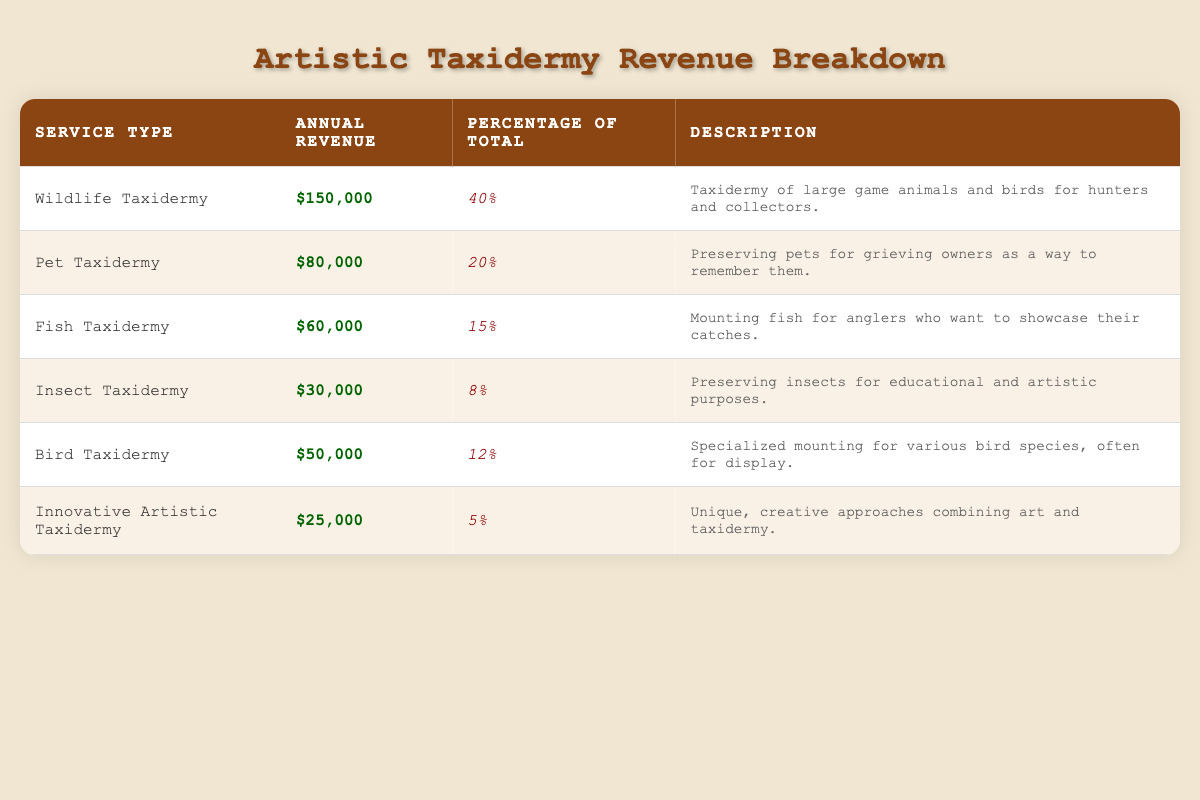What is the annual revenue from Wildlife Taxidermy? The table lists the annual revenue for Wildlife Taxidermy as $150,000. This value can be found directly in the "Annual Revenue" column for the corresponding service type.
Answer: $150,000 What percentage of total revenue does Fish Taxidermy account for? The table indicates that Fish Taxidermy accounts for 15% of the total revenue, as noted in the "Percentage of Total" column next to the Fish Taxidermy service type.
Answer: 15% Which taxidermy service has the least annual revenue? By reviewing the "Annual Revenue" column, Innovative Artistic Taxidermy shows the least revenue at $25,000 when compared to all other service types.
Answer: Innovative Artistic Taxidermy What is the total annual revenue from Pet Taxidermy and Bird Taxidermy combined? The annual revenue for Pet Taxidermy is $80,000 and for Bird Taxidermy it is $50,000. Adding these together (80,000 + 50,000) equals $130,000. This total is derived by combining the individual revenues of the two service types.
Answer: $130,000 Is the revenue from Insect Taxidermy greater than that from Fish Taxidermy? The revenue from Insect Taxidermy is $30,000 and the revenue from Fish Taxidermy is $60,000. Since $30,000 is less than $60,000, the statement is false. This comparison is based on the "Annual Revenue" values for both service types in the table.
Answer: No What is the average annual revenue of the taxidermy services listed? To find the average, first sum the individual revenues: $150,000 + $80,000 + $60,000 + $30,000 + $50,000 + $25,000 = $395,000. There are 6 services, so the average revenue is $395,000 divided by 6, which equals approximately $65,833.33. This is calculated by dividing the total revenue by the number of services.
Answer: $65,833.33 Which service type contributes most to the total revenue? Wildlife Taxidermy contributes the most, with an annual revenue of $150,000. This is identified by comparing the "Annual Revenue" figures across all service types and selecting the highest one.
Answer: Wildlife Taxidermy Is the total percentage of Pet Taxidermy and Innovative Artistic Taxidermy greater than 30%? Pet Taxidermy accounts for 20% and Innovative Artistic Taxidermy accounts for 5%. Adding these two percentages together (20% + 5%) gives a total of 25%, which is less than 30%. Therefore, the statement is false. This assessment is based on the "Percentage of Total" values for both service types.
Answer: No What is the difference in annual revenue between Wildlife Taxidermy and Pet Taxidermy? The annual revenue for Wildlife Taxidermy is $150,000, and for Pet Taxidermy, it is $80,000. The difference can be found by subtracting the revenue of Pet Taxidermy from that of Wildlife Taxidermy (150,000 - 80,000), which results in $70,000. This calculation shows how much more Wildlife Taxidermy earns compared to Pet Taxidermy.
Answer: $70,000 